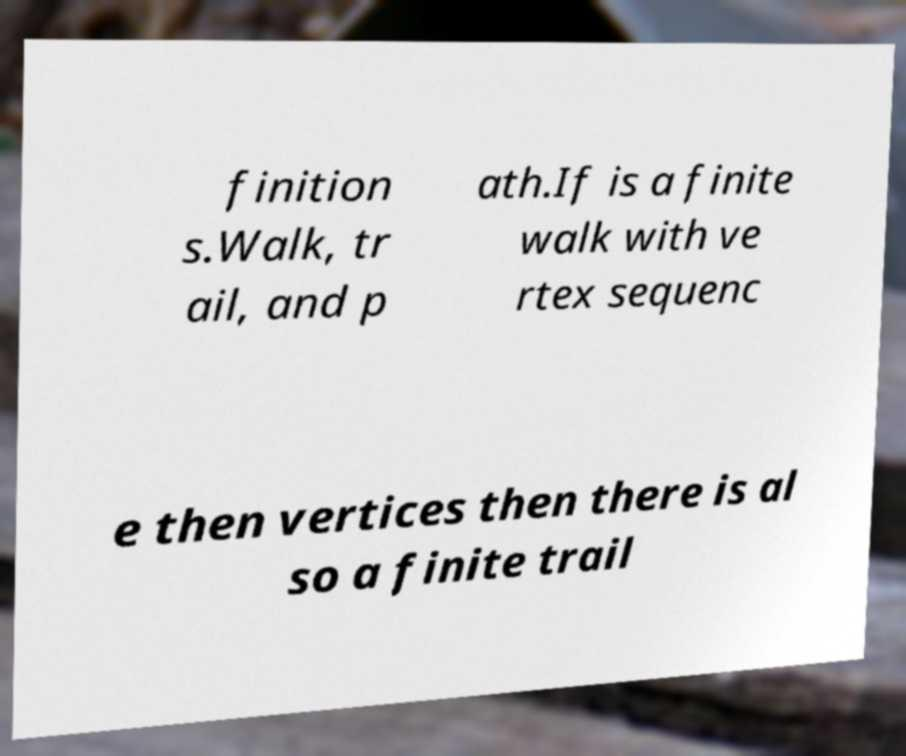Please read and relay the text visible in this image. What does it say? finition s.Walk, tr ail, and p ath.If is a finite walk with ve rtex sequenc e then vertices then there is al so a finite trail 